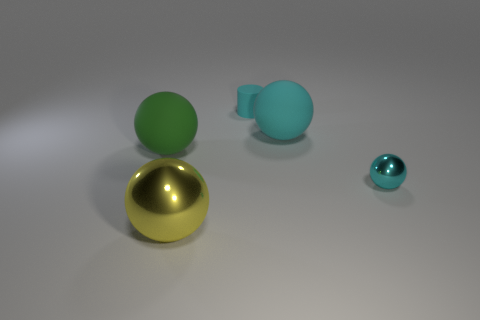What color is the other metal thing that is the same shape as the large shiny object?
Give a very brief answer. Cyan. What shape is the tiny thing in front of the large rubber sphere to the left of the rubber ball that is to the right of the yellow shiny ball?
Ensure brevity in your answer.  Sphere. There is a object that is both behind the small sphere and to the left of the tiny rubber cylinder; what is its size?
Your answer should be compact. Large. Are there fewer large red matte cylinders than yellow things?
Provide a succinct answer. Yes. How big is the sphere that is in front of the tiny ball?
Provide a succinct answer. Large. There is a big object that is to the right of the green rubber thing and behind the cyan metal object; what is its shape?
Ensure brevity in your answer.  Sphere. What size is the cyan matte object that is the same shape as the big shiny thing?
Ensure brevity in your answer.  Large. How many cyan objects have the same material as the green sphere?
Make the answer very short. 2. Does the tiny matte cylinder have the same color as the thing in front of the small metallic ball?
Your response must be concise. No. Are there more tiny red matte spheres than matte cylinders?
Make the answer very short. No. 